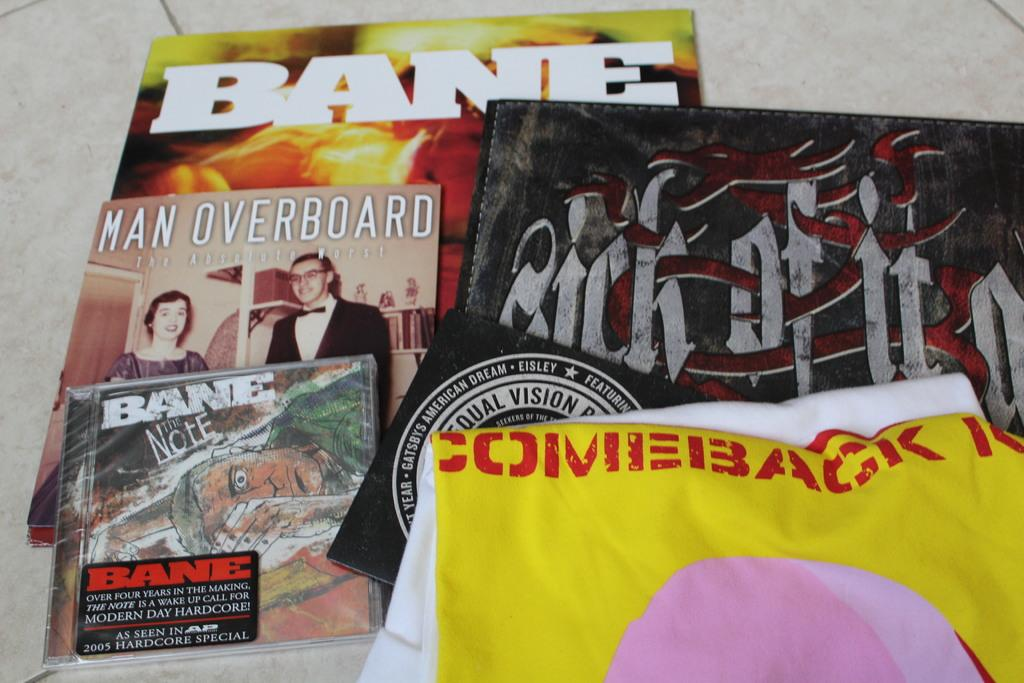What type of clothing item is visible in the image? There is a t-shirt in the image. What else can be seen in the image besides the t-shirt? There are books in the image. Where are the t-shirt and books located in the image? Both the t-shirt and books are on a surface. Is there a park visible in the image? There is no mention of a park in the provided facts, so it cannot be determined if one is visible in the image. 